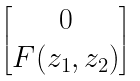<formula> <loc_0><loc_0><loc_500><loc_500>\begin{bmatrix} 0 \\ F ( z _ { 1 } , z _ { 2 } ) \end{bmatrix}</formula> 